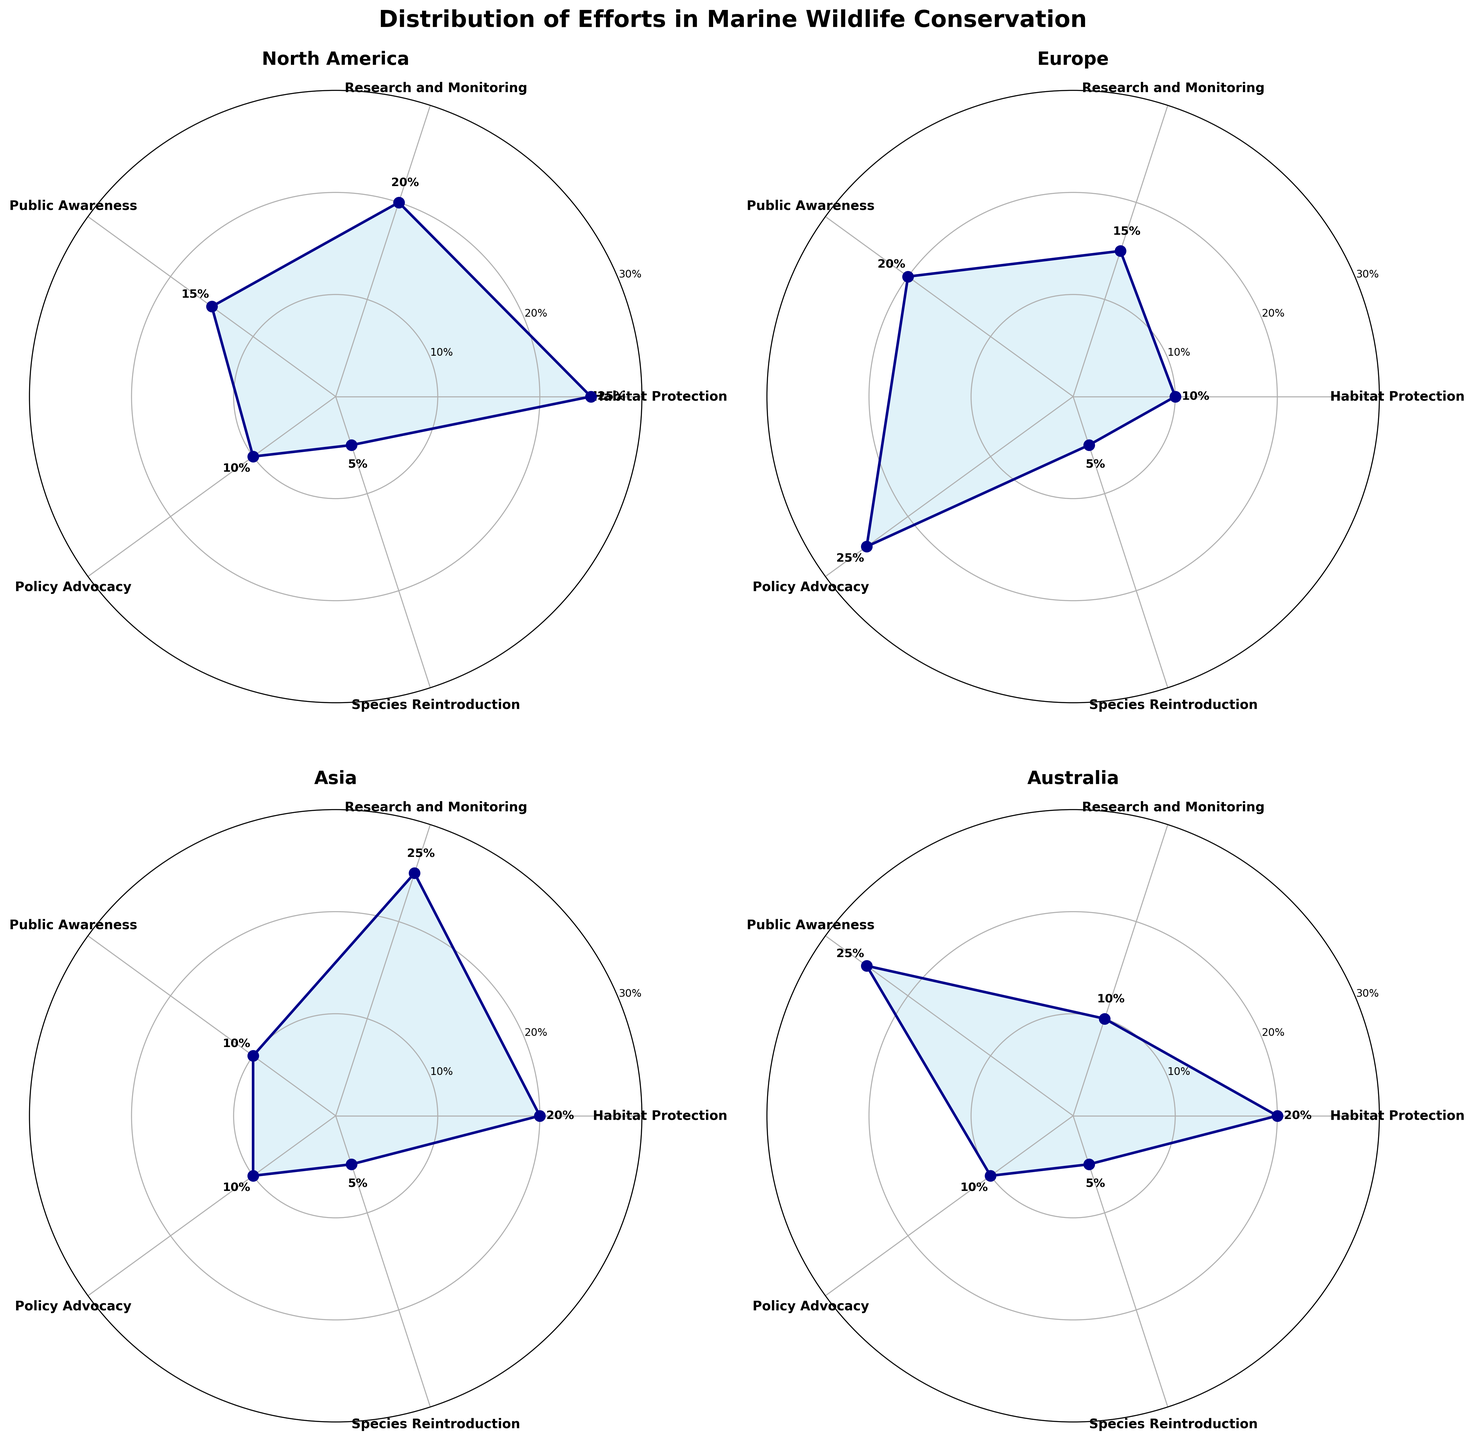What is the title of the figure? The title is located at the top of the figure and is clearly stated in a bold font.
Answer: Distribution of Efforts in Marine Wildlife Conservation Which region has the highest percentage for Habitat Protection? By looking at the plotted data, the highest value for Habitat Protection is in North America, indicated by the marked data point and its associated label.
Answer: North America How do the percentages for Species Reintroduction compare among the regions? Examine the radial position of the data points labeled "Species Reintroduction" for each region. All these points are listed as 5%, making them equal across all regions.
Answer: They are equal What is the sum of the percentages for Research and Monitoring in North America and Asia? North America's Research and Monitoring percentage is 20% and Asia's is 25%. Adding these two values gives us 20% + 25%.
Answer: 45% Which region has the highest overall percentage for Public Awareness initiatives? By reviewing the plotted data for Public Awareness, Australia's percentage is the highest compared to other regions.
Answer: Australia What percentage does Europe allocate to Policy Advocacy? By finding the label associated with Policy Advocacy on Europe’s plot, it is marked at 25%.
Answer: 25% Compare the percentages for Habitat Protection between North America and Asia. Which region allocates more effort to it? North America's Habitat Protection is 25%, while Asia's is 20%. Thus, North America allocates more effort.
Answer: North America What's the average percentage of Policy Advocacy across all regions? Add the percentages for Policy Advocacy from all regions: 10% (North America) + 25% (Europe) + 10% (Asia) + 10% (Australia) = 55%. Then divide by the number of regions (4). 55% / 4 = 13.75%.
Answer: 13.75% In which region are Public Awareness and Species Reintroduction initiatives given equal attention? The plots show the percentages for Public Awareness and Species Reintroduction. Europe has Public Awareness at 20% and Species Reintroduction at 5%, so they are not equal. In Australia, Public Awareness is at 25% and Species Reintroduction at 5%, so they are not equal. North America and Asia also show differences in these percentages.
Answer: None Compare the efforts in Research and Monitoring between Europe and Australia. Which region prioritizes this initiative more? By observing the data points for Research and Monitoring, Europe allocates 15%, while Australia allocates 10%. Europe prioritizes this initiative more.
Answer: Europe 